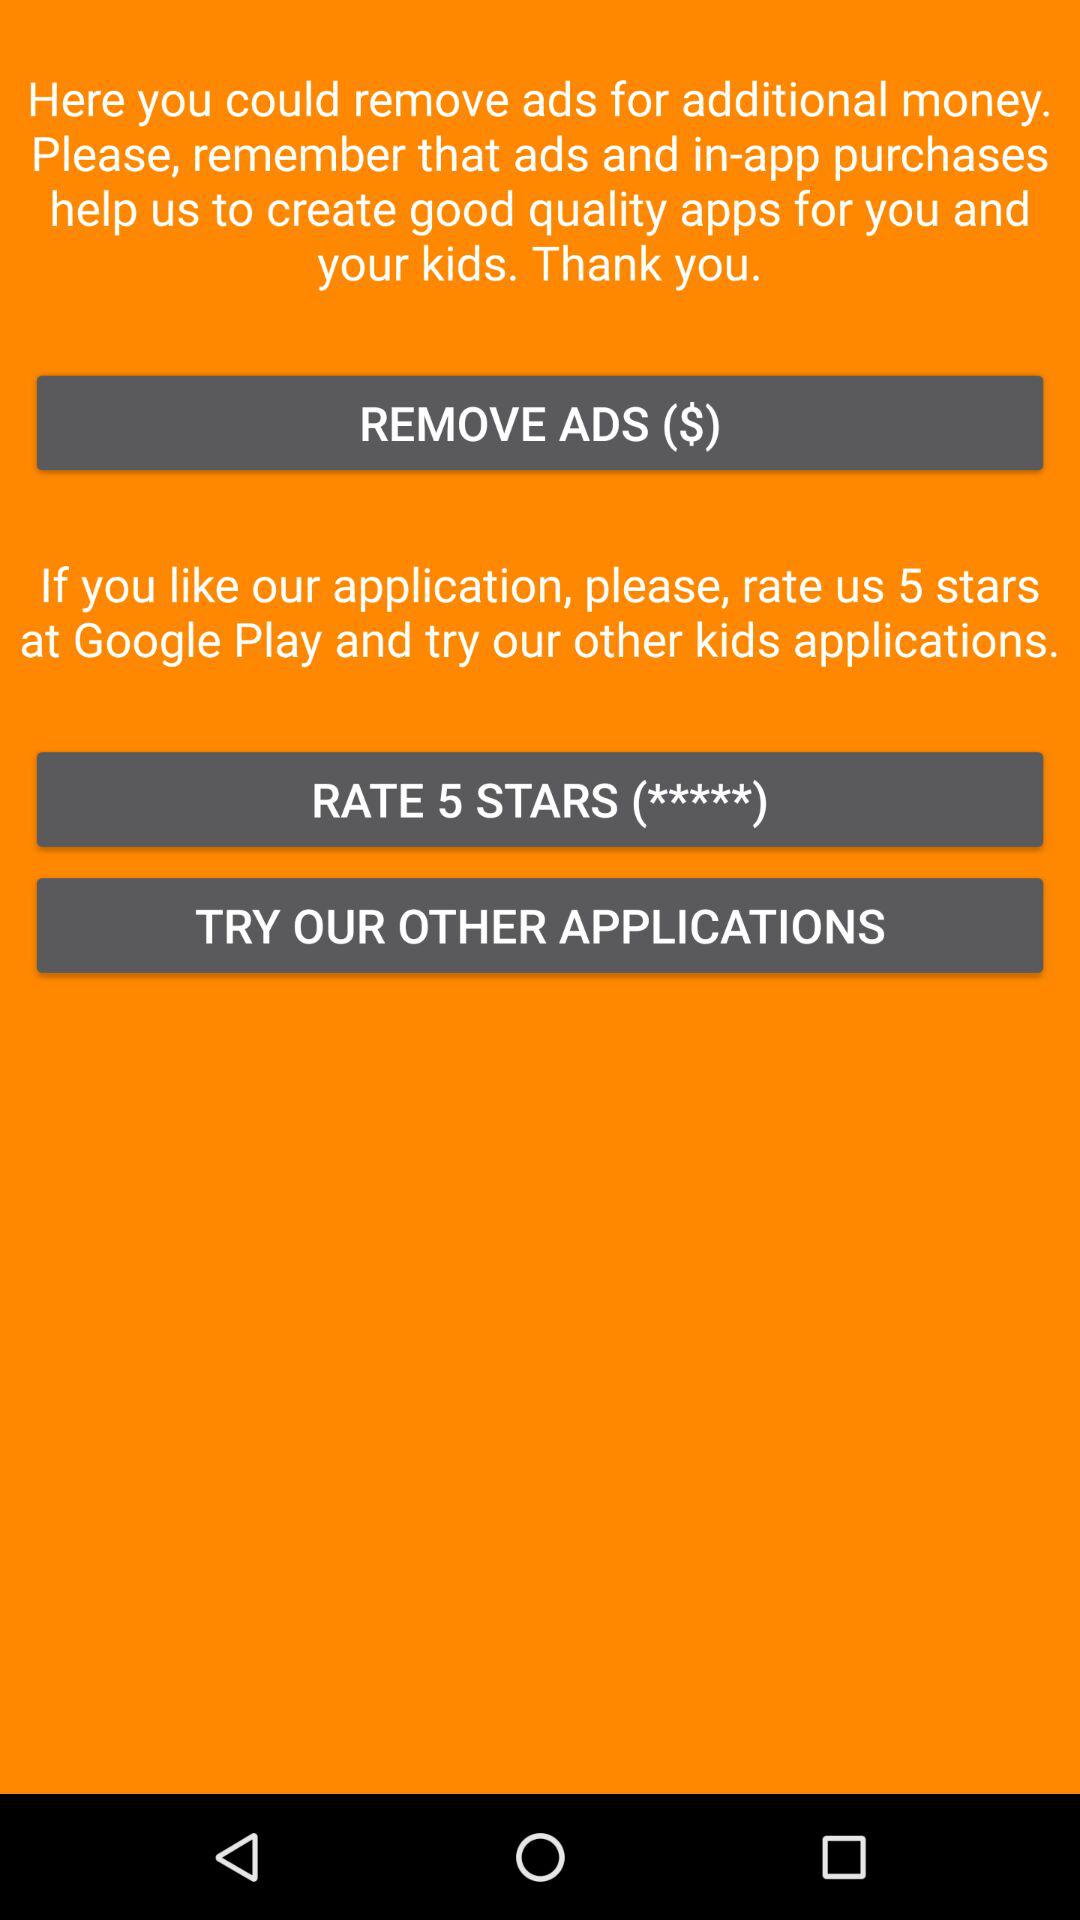How many stars can be given to the app? The app can be given 5 stars. 